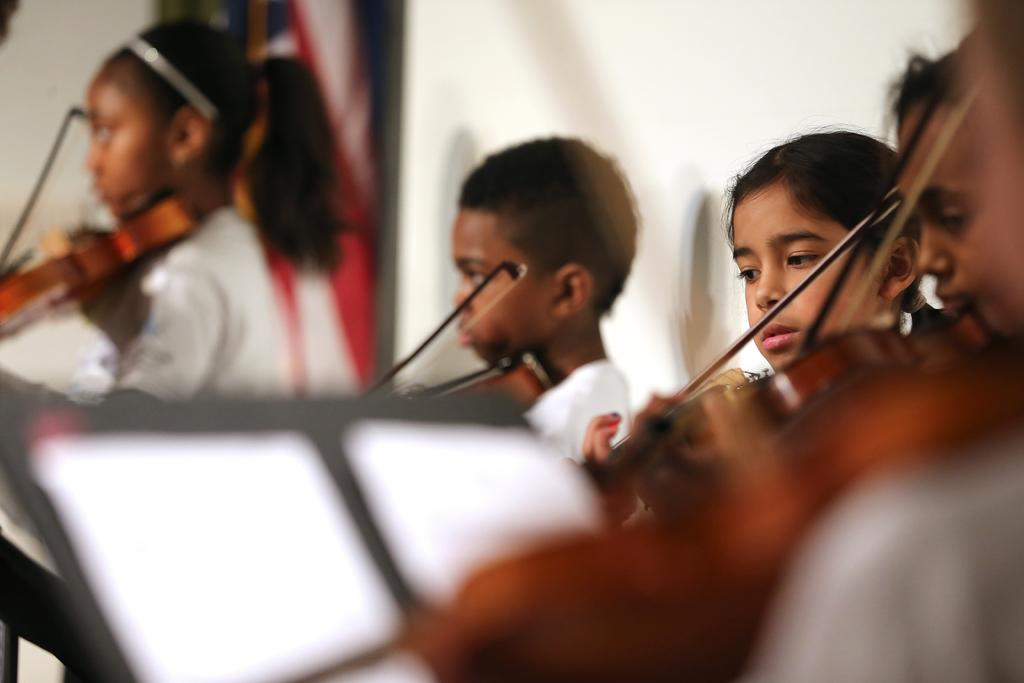How many children are present in the image? There are four children in the image. What are the children doing in the image? Each child is holding a musical instrument. Can you see any socks on the children's feet in the image? The image does not show the children's feet or any socks they might be wearing. 